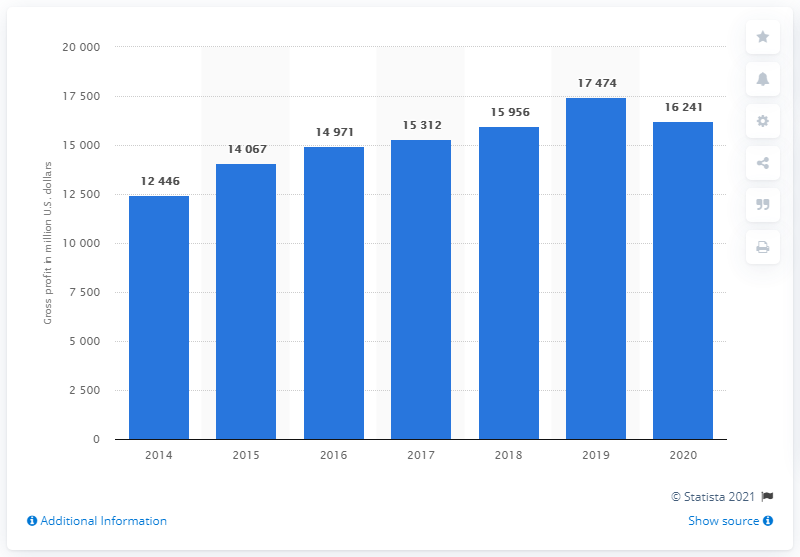Can you describe the trend in Nike's global gross profit from 2014 to 2020? The bar chart depicts a general upward trend in Nike's global gross profit over the years from 2014 to 2020, starting at $12.446 billion in 2014 and peaking at $17.474 billion in 2019 before slightly decreasing to $16.241 billion in 2020.  Why might there have been a decrease in the gross profit in 2020 compared to 2019? While the image doesn't provide explicit reasons, the decrease in 2020's gross profit compared to 2019 could potentially be attributed to external factors such as the global COVID-19 pandemic, which created economic disruptions, supply chain challenges, and changes in consumer behavior affecting many businesses worldwide. 